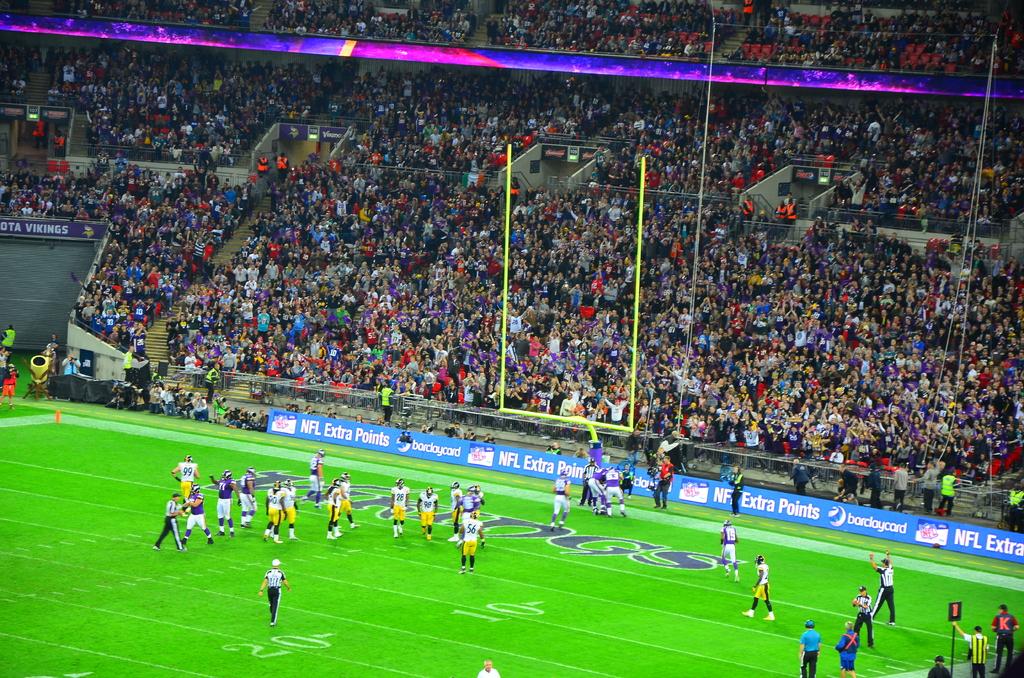What league of game is this?
Give a very brief answer. Nfl. 